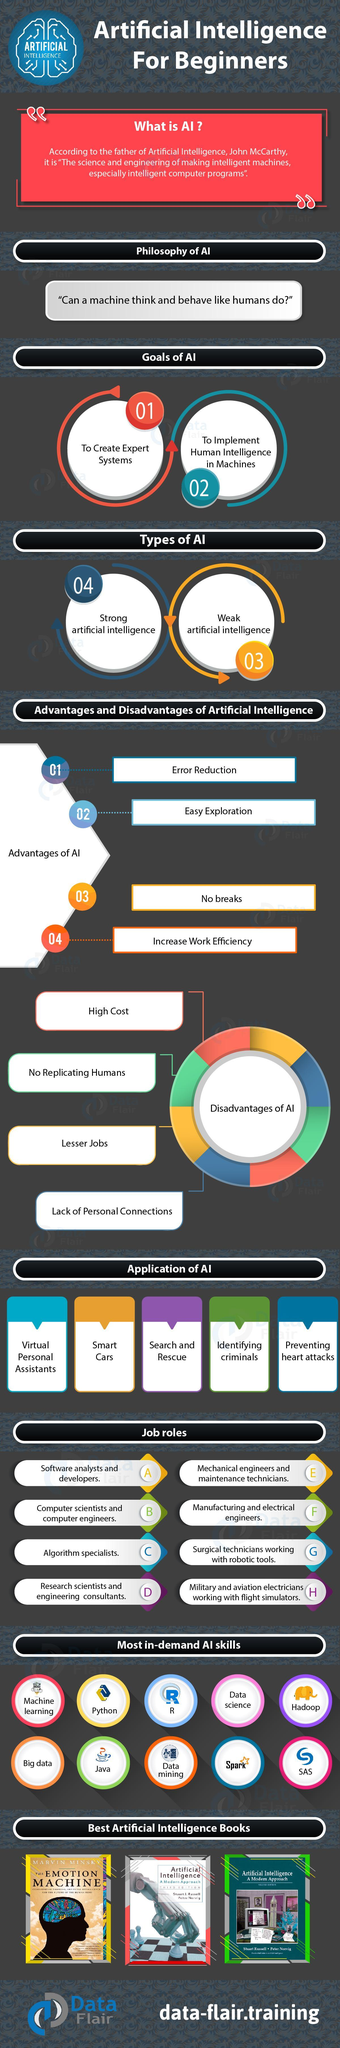What is the AI job role in surgery?
Answer the question with a short phrase. Surgical technicians working with robotic tools Which is the AI skill shown in the yellow circle? Python What are the first two advantages of AI? Error reduction, easy exploration Who can work with 'no breaks', AI or humans? AI What is the science of making intelligent machines and computer programs? Artificial intelligence Who are the authors of "Artificial intelligence A Modern approach"? Stuart Russell, Peter Norvig How many most-in-demand AI skills are mentioned? 10 Which are the first three disadvantages of artificial intelligence? High cost, no replicating humans, lesser jobs How many advantages of artificial intelligence are mentioned? 4 Who is the author of 'The emotion machine'? Marvin Minsky Which of these is an AI skill - high cost, Java or lesser jobs? Java What are the types of AI? Strong artificial intelligence, weak artificial intelligence Who can make a better personal connection, AI or humans? Humans Who can work with lesser errors, humans or artificial intelligence? Artificial intelligence How many applications of artificial intelligence are mentioned? 5 How many AI job roles are mentioned? 8 Name the first three applications of AI mentioned here? Virtual personal assistants, smart cars, search and rescue What is the AI job role in the military and aviation? Military and aviation electricians working with flight simulators On what fundamental philosophy is artificial intelligence based? Can a machine think and behave like humans do? How many artificial intelligence books are shown here? 3 Which is the third AI job role mentioned? Algorithm specialists 